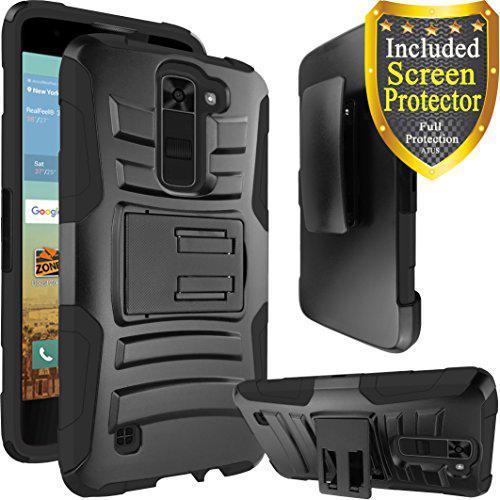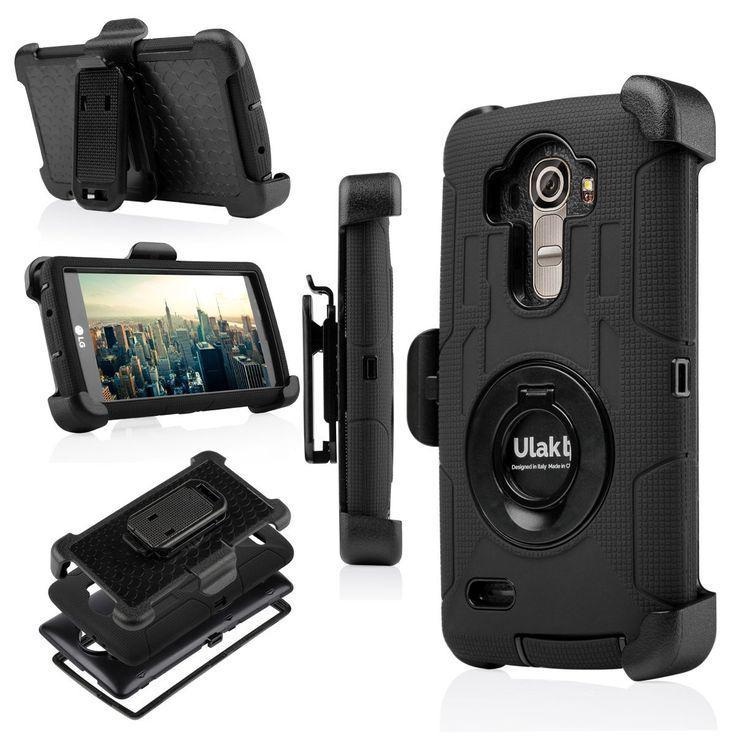The first image is the image on the left, the second image is the image on the right. For the images shown, is this caption "One image shows a group of five items showing configurations of a device that is black and one other color, and the other image shows a rectangular device in two side-by-side views." true? Answer yes or no. No. 